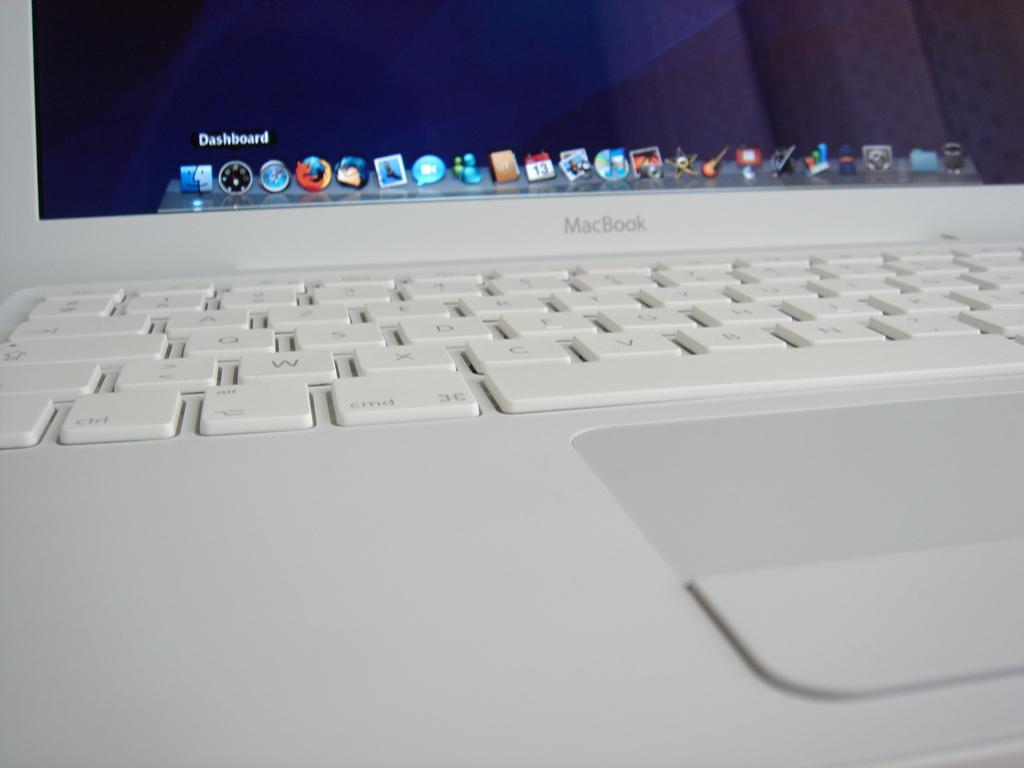<image>
Offer a succinct explanation of the picture presented. A keyboard and the bottom part of the screen for a white macbook. 